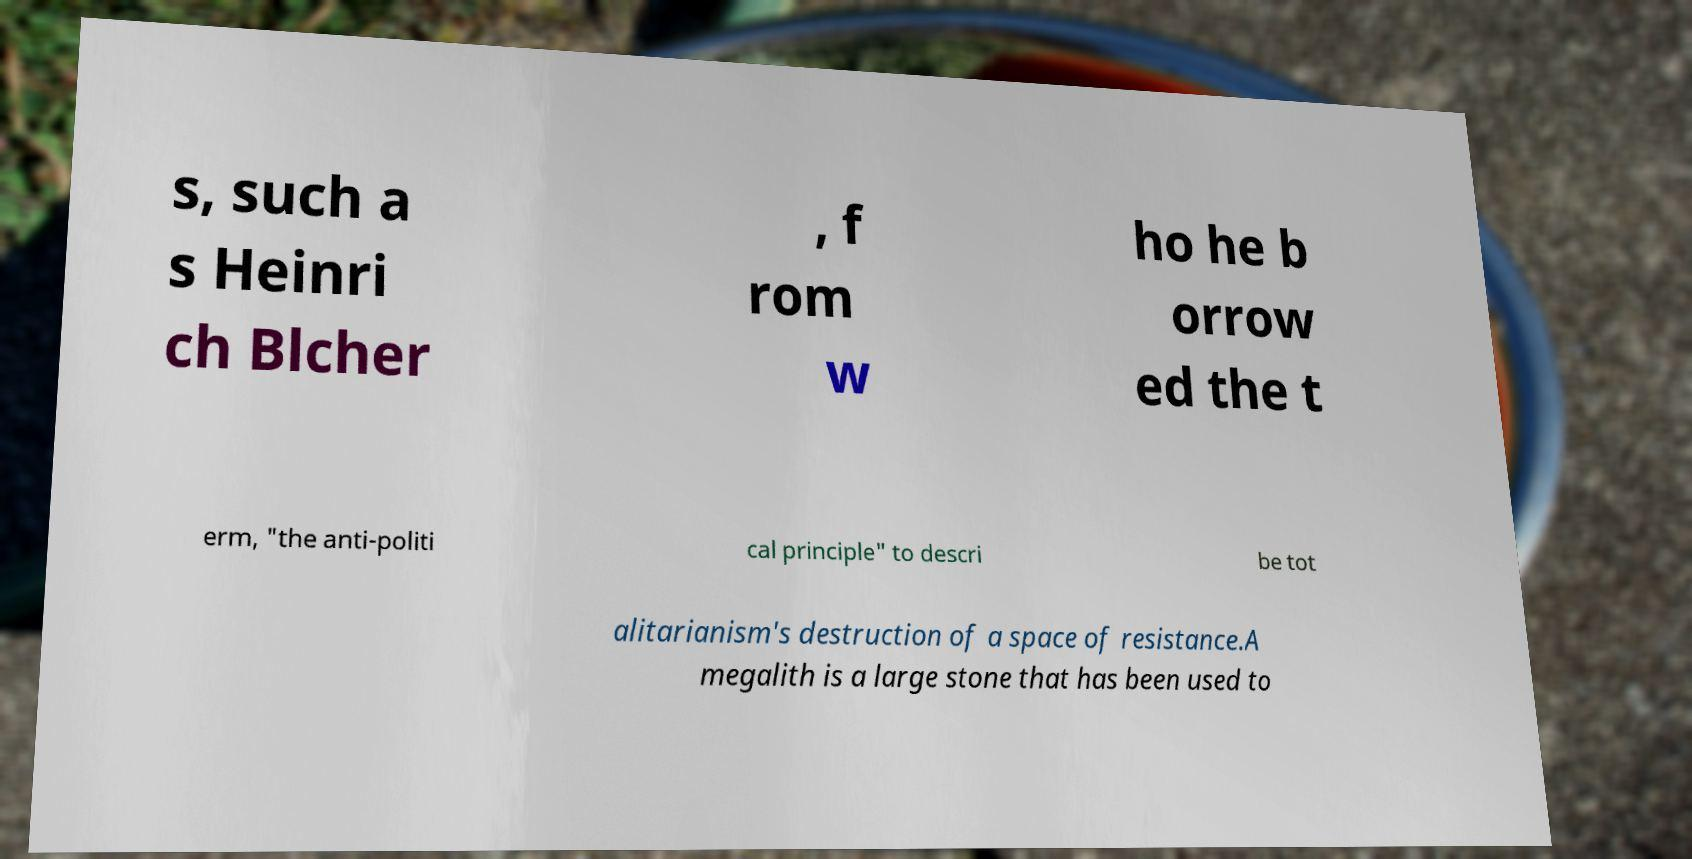What messages or text are displayed in this image? I need them in a readable, typed format. s, such a s Heinri ch Blcher , f rom w ho he b orrow ed the t erm, "the anti-politi cal principle" to descri be tot alitarianism's destruction of a space of resistance.A megalith is a large stone that has been used to 